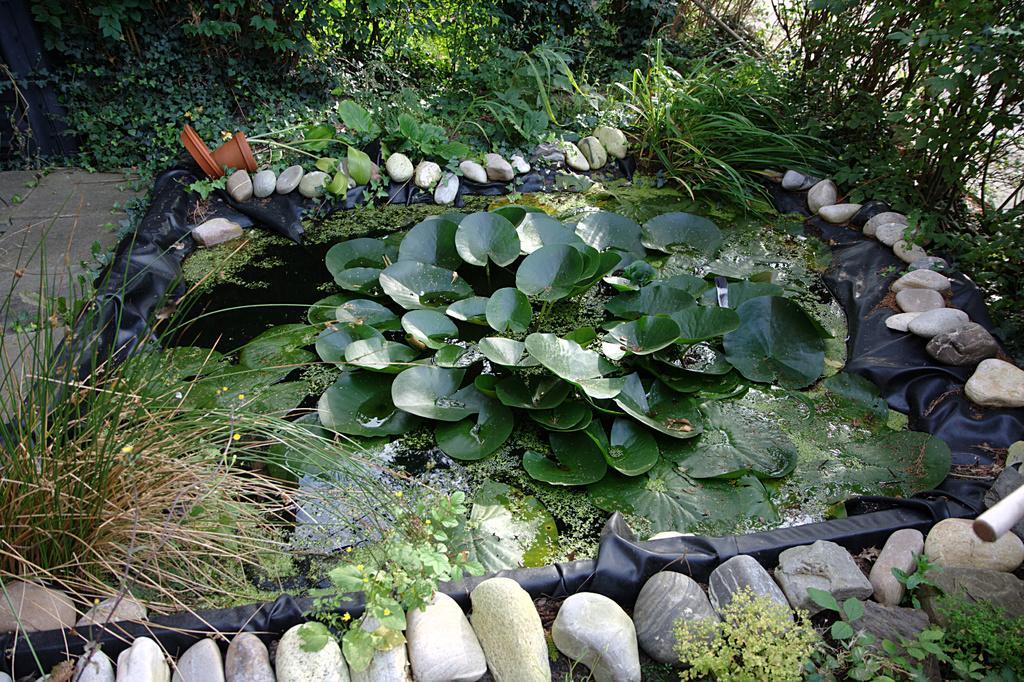Describe this image in one or two sentences. In this image, I can see the leaves floating on the water. These are the rocks. This looks like a black sheet. I can see the trees and plants. This looks like a flower pot with a plant in it. 